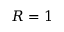<formula> <loc_0><loc_0><loc_500><loc_500>R = 1</formula> 